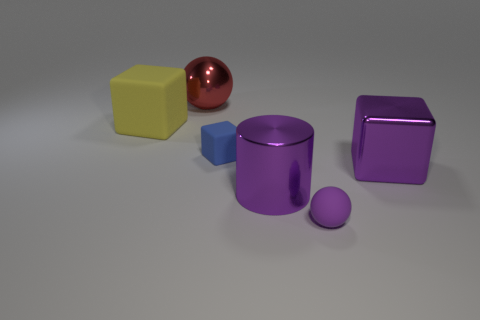Add 1 tiny balls. How many objects exist? 7 Subtract all spheres. How many objects are left? 4 Add 5 blocks. How many blocks exist? 8 Subtract 0 cyan cylinders. How many objects are left? 6 Subtract all large cylinders. Subtract all tiny spheres. How many objects are left? 4 Add 5 yellow matte blocks. How many yellow matte blocks are left? 6 